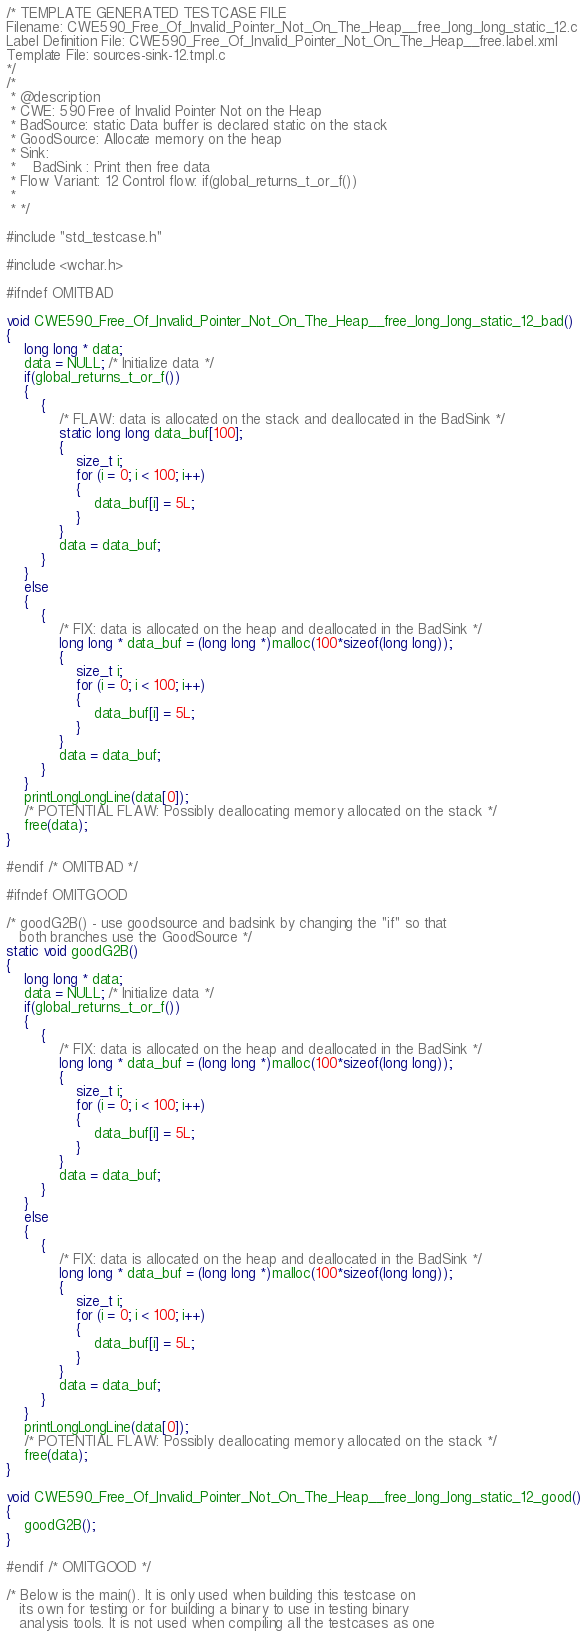Convert code to text. <code><loc_0><loc_0><loc_500><loc_500><_C_>/* TEMPLATE GENERATED TESTCASE FILE
Filename: CWE590_Free_Of_Invalid_Pointer_Not_On_The_Heap__free_long_long_static_12.c
Label Definition File: CWE590_Free_Of_Invalid_Pointer_Not_On_The_Heap__free.label.xml
Template File: sources-sink-12.tmpl.c
*/
/*
 * @description
 * CWE: 590 Free of Invalid Pointer Not on the Heap
 * BadSource: static Data buffer is declared static on the stack
 * GoodSource: Allocate memory on the heap
 * Sink:
 *    BadSink : Print then free data
 * Flow Variant: 12 Control flow: if(global_returns_t_or_f())
 *
 * */

#include "std_testcase.h"

#include <wchar.h>

#ifndef OMITBAD

void CWE590_Free_Of_Invalid_Pointer_Not_On_The_Heap__free_long_long_static_12_bad()
{
    long long * data;
    data = NULL; /* Initialize data */
    if(global_returns_t_or_f())
    {
        {
            /* FLAW: data is allocated on the stack and deallocated in the BadSink */
            static long long data_buf[100];
            {
                size_t i;
                for (i = 0; i < 100; i++)
                {
                    data_buf[i] = 5L;
                }
            }
            data = data_buf;
        }
    }
    else
    {
        {
            /* FIX: data is allocated on the heap and deallocated in the BadSink */
            long long * data_buf = (long long *)malloc(100*sizeof(long long));
            {
                size_t i;
                for (i = 0; i < 100; i++)
                {
                    data_buf[i] = 5L;
                }
            }
            data = data_buf;
        }
    }
    printLongLongLine(data[0]);
    /* POTENTIAL FLAW: Possibly deallocating memory allocated on the stack */
    free(data);
}

#endif /* OMITBAD */

#ifndef OMITGOOD

/* goodG2B() - use goodsource and badsink by changing the "if" so that
   both branches use the GoodSource */
static void goodG2B()
{
    long long * data;
    data = NULL; /* Initialize data */
    if(global_returns_t_or_f())
    {
        {
            /* FIX: data is allocated on the heap and deallocated in the BadSink */
            long long * data_buf = (long long *)malloc(100*sizeof(long long));
            {
                size_t i;
                for (i = 0; i < 100; i++)
                {
                    data_buf[i] = 5L;
                }
            }
            data = data_buf;
        }
    }
    else
    {
        {
            /* FIX: data is allocated on the heap and deallocated in the BadSink */
            long long * data_buf = (long long *)malloc(100*sizeof(long long));
            {
                size_t i;
                for (i = 0; i < 100; i++)
                {
                    data_buf[i] = 5L;
                }
            }
            data = data_buf;
        }
    }
    printLongLongLine(data[0]);
    /* POTENTIAL FLAW: Possibly deallocating memory allocated on the stack */
    free(data);
}

void CWE590_Free_Of_Invalid_Pointer_Not_On_The_Heap__free_long_long_static_12_good()
{
    goodG2B();
}

#endif /* OMITGOOD */

/* Below is the main(). It is only used when building this testcase on
   its own for testing or for building a binary to use in testing binary
   analysis tools. It is not used when compiling all the testcases as one</code> 